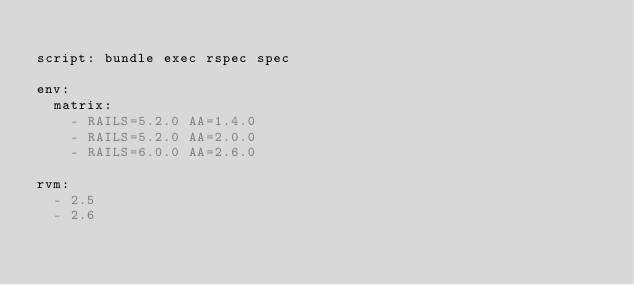<code> <loc_0><loc_0><loc_500><loc_500><_YAML_>
script: bundle exec rspec spec

env:
  matrix:
    - RAILS=5.2.0 AA=1.4.0
    - RAILS=5.2.0 AA=2.0.0
    - RAILS=6.0.0 AA=2.6.0

rvm:
  - 2.5
  - 2.6
</code> 